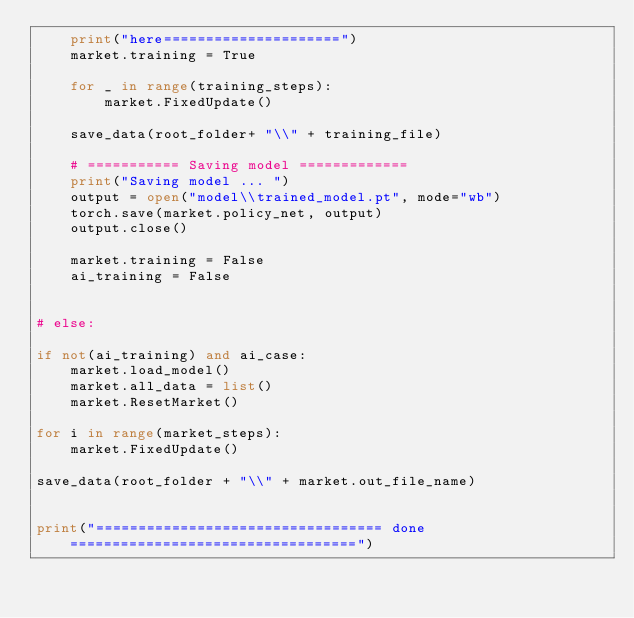Convert code to text. <code><loc_0><loc_0><loc_500><loc_500><_Python_>    print("here=====================")
    market.training = True

    for _ in range(training_steps):
        market.FixedUpdate()

    save_data(root_folder+ "\\" + training_file)

    # =========== Saving model =============
    print("Saving model ... ")
    output = open("model\\trained_model.pt", mode="wb")
    torch.save(market.policy_net, output)
    output.close() 
    
    market.training = False
    ai_training = False
    

# else:

if not(ai_training) and ai_case:
    market.load_model()
    market.all_data = list()
    market.ResetMarket()

for i in range(market_steps):
    market.FixedUpdate()

save_data(root_folder + "\\" + market.out_file_name)


print("================================== done ==================================")</code> 